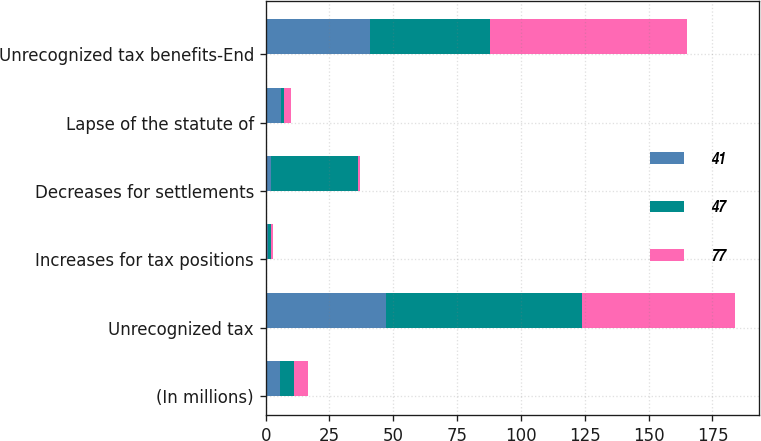Convert chart. <chart><loc_0><loc_0><loc_500><loc_500><stacked_bar_chart><ecel><fcel>(In millions)<fcel>Unrecognized tax<fcel>Increases for tax positions<fcel>Decreases for settlements<fcel>Lapse of the statute of<fcel>Unrecognized tax benefits-End<nl><fcel>41<fcel>5.5<fcel>47<fcel>1<fcel>2<fcel>6<fcel>41<nl><fcel>47<fcel>5.5<fcel>77<fcel>1<fcel>34<fcel>1<fcel>47<nl><fcel>77<fcel>5.5<fcel>60<fcel>1<fcel>1<fcel>3<fcel>77<nl></chart> 